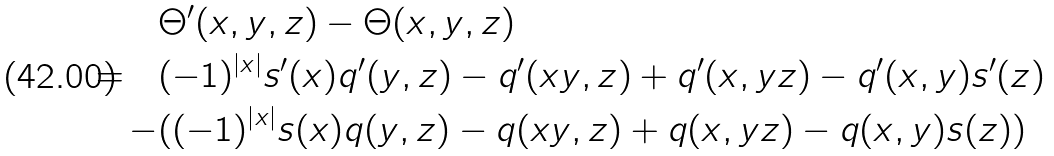<formula> <loc_0><loc_0><loc_500><loc_500>& \Theta ^ { \prime } ( x , y , z ) - \Theta ( x , y , z ) \\ = \quad & ( - 1 ) ^ { \left | x \right | } s ^ { \prime } ( x ) q ^ { \prime } ( y , z ) - q ^ { \prime } ( x y , z ) + q ^ { \prime } ( x , y z ) - q ^ { \prime } ( x , y ) s ^ { \prime } ( z ) \\ - & ( ( - 1 ) ^ { \left | x \right | } s ( x ) q ( y , z ) - q ( x y , z ) + q ( x , y z ) - q ( x , y ) s ( z ) )</formula> 